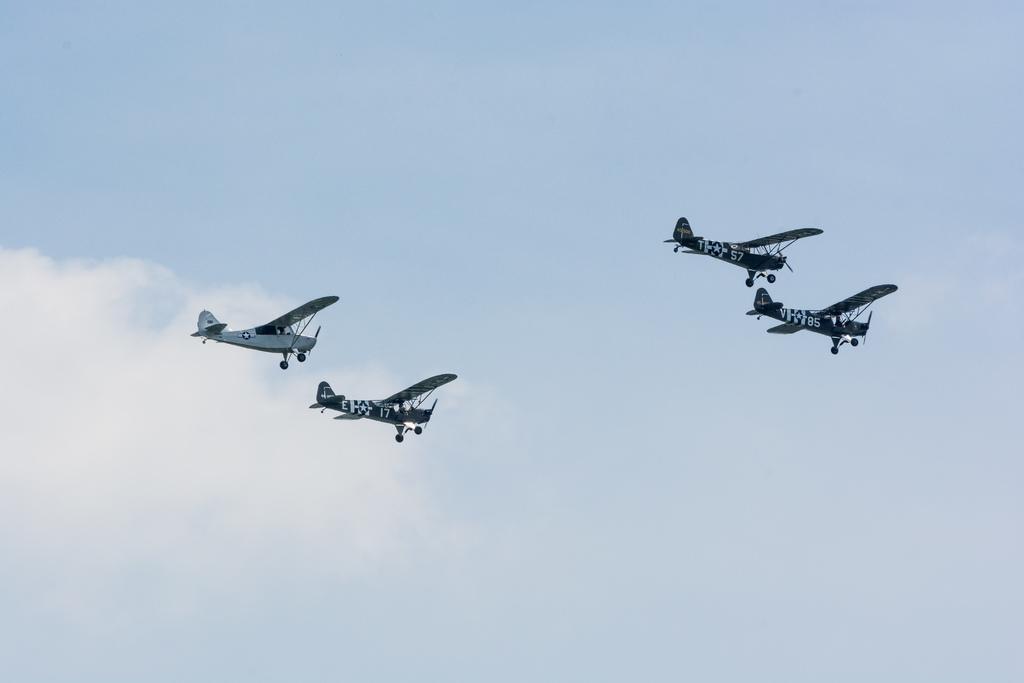Describe this image in one or two sentences. In this picture we can see airplanes flying and in the background we can see sky with clouds. 